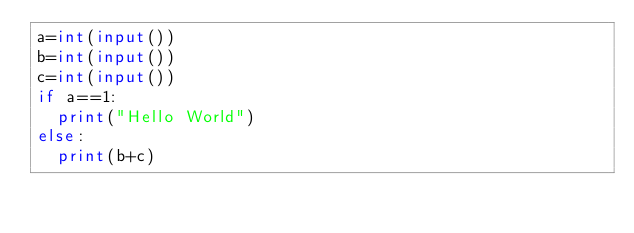Convert code to text. <code><loc_0><loc_0><loc_500><loc_500><_Python_>a=int(input())
b=int(input())
c=int(input())
if a==1:
  print("Hello World")
else:
  print(b+c)</code> 